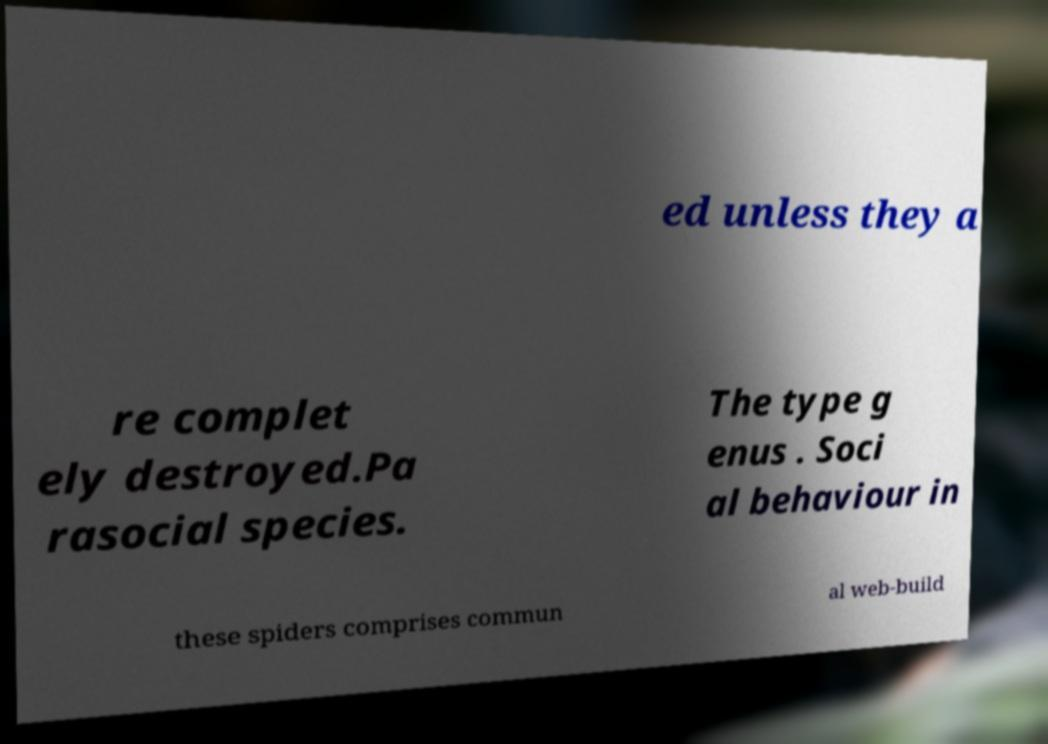What messages or text are displayed in this image? I need them in a readable, typed format. ed unless they a re complet ely destroyed.Pa rasocial species. The type g enus . Soci al behaviour in these spiders comprises commun al web-build 